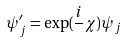<formula> <loc_0><loc_0><loc_500><loc_500>\psi _ { j } ^ { \prime } = \exp ( \frac { i } { } \chi ) \psi _ { j }</formula> 